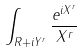Convert formula to latex. <formula><loc_0><loc_0><loc_500><loc_500>\int _ { { R } + i Y ^ { r } } \frac { e ^ { i X ^ { r } } } { X ^ { r } }</formula> 